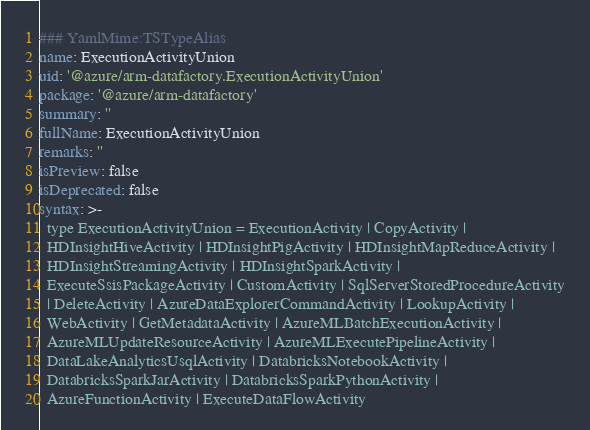Convert code to text. <code><loc_0><loc_0><loc_500><loc_500><_YAML_>### YamlMime:TSTypeAlias
name: ExecutionActivityUnion
uid: '@azure/arm-datafactory.ExecutionActivityUnion'
package: '@azure/arm-datafactory'
summary: ''
fullName: ExecutionActivityUnion
remarks: ''
isPreview: false
isDeprecated: false
syntax: >-
  type ExecutionActivityUnion = ExecutionActivity | CopyActivity |
  HDInsightHiveActivity | HDInsightPigActivity | HDInsightMapReduceActivity |
  HDInsightStreamingActivity | HDInsightSparkActivity |
  ExecuteSsisPackageActivity | CustomActivity | SqlServerStoredProcedureActivity
  | DeleteActivity | AzureDataExplorerCommandActivity | LookupActivity |
  WebActivity | GetMetadataActivity | AzureMLBatchExecutionActivity |
  AzureMLUpdateResourceActivity | AzureMLExecutePipelineActivity |
  DataLakeAnalyticsUsqlActivity | DatabricksNotebookActivity |
  DatabricksSparkJarActivity | DatabricksSparkPythonActivity |
  AzureFunctionActivity | ExecuteDataFlowActivity
</code> 